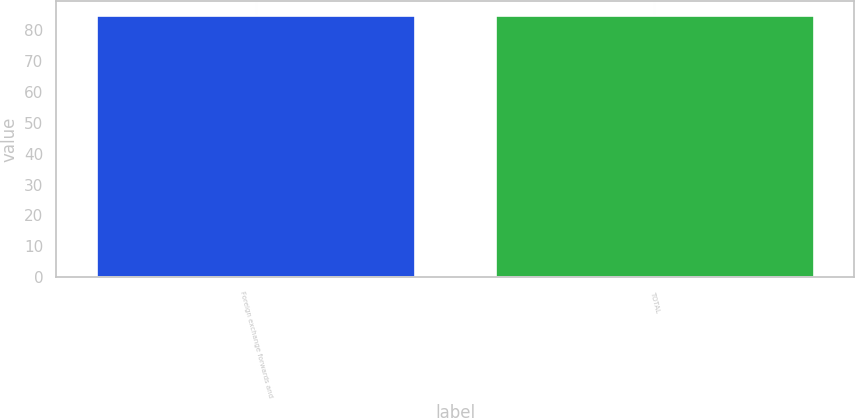Convert chart to OTSL. <chart><loc_0><loc_0><loc_500><loc_500><bar_chart><fcel>Foreign exchange forwards and<fcel>TOTAL<nl><fcel>85<fcel>85.1<nl></chart> 